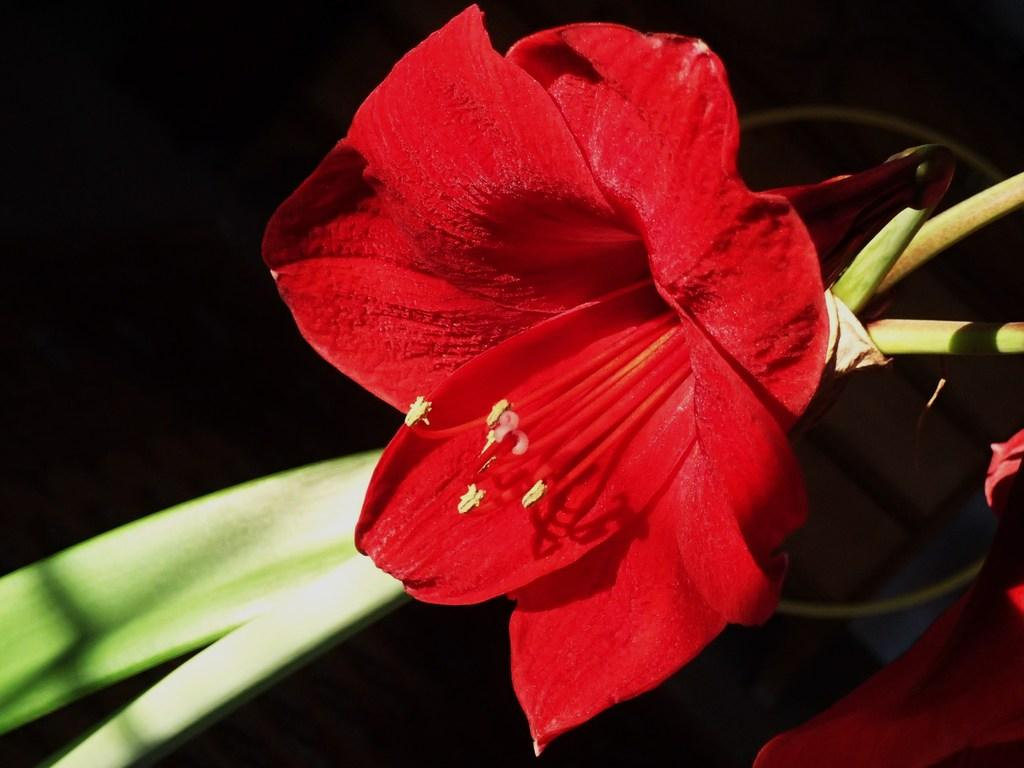What is the main subject of the image? The main subject of the image is a beautiful red flower. Where is the flower located? The flower is on a plant. What is the color of the flower? The flower is red. What can be seen in the background of the image? The background of the image is dark. What type of afterthought can be seen in the image? There is no afterthought present in the image; it features a beautiful red flower on a plant. Can you tell me how many turkeys are visible in the image? There are no turkeys present in the image. What type of vacation destination is depicted in the image? The image does not depict a vacation destination; it features a beautiful red flower on a plant. 